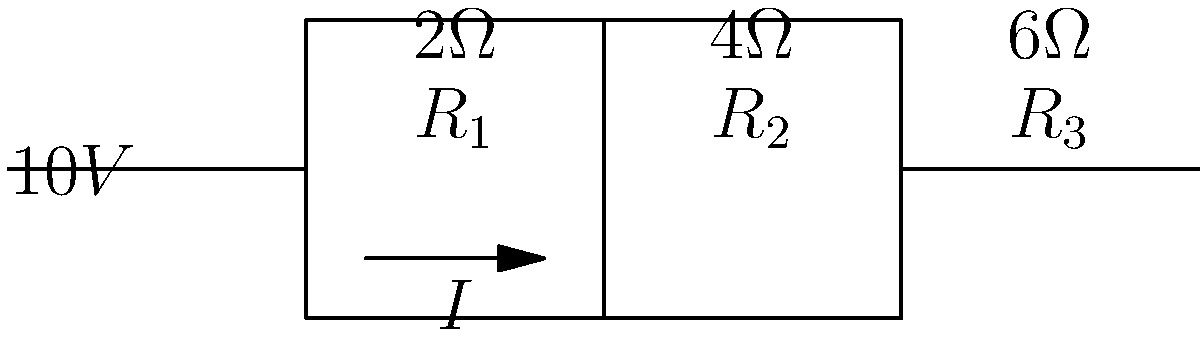In this unique circuit puzzle, you're tasked with uncovering the hidden voltage drop across $R_2$. The circuit contains three resistors in a series-parallel configuration, powered by a 10V source. $R_1 = 2\Omega$, $R_2 = 4\Omega$, and $R_3 = 6\Omega$. Can you crack the code and determine the voltage drop across $R_2$? Let's approach this puzzle step-by-step:

1) First, we need to calculate the total resistance of the circuit:
   $R_{total} = R_1 + (R_2 \parallel R_3)$
   
2) To find $R_2 \parallel R_3$:
   $\frac{1}{R_{23}} = \frac{1}{R_2} + \frac{1}{R_3} = \frac{1}{4} + \frac{1}{6} = \frac{5}{12}$
   $R_{23} = \frac{12}{5} = 2.4\Omega$

3) Now, $R_{total} = 2\Omega + 2.4\Omega = 4.4\Omega$

4) We can calculate the current using Ohm's law:
   $I = \frac{V}{R_{total}} = \frac{10V}{4.4\Omega} = 2.27A$

5) This current flows through $R_1$ and splits between $R_2$ and $R_3$. To find the current through $R_2$, we use the current divider rule:
   $I_{R2} = I \cdot \frac{R_3}{R_2 + R_3} = 2.27A \cdot \frac{6\Omega}{4\Omega + 6\Omega} = 1.362A$

6) Finally, we can calculate the voltage drop across $R_2$ using Ohm's law:
   $V_{R2} = I_{R2} \cdot R_2 = 1.362A \cdot 4\Omega = 5.448V$

Thus, the voltage drop across $R_2$ is approximately 5.45V.
Answer: 5.45V 